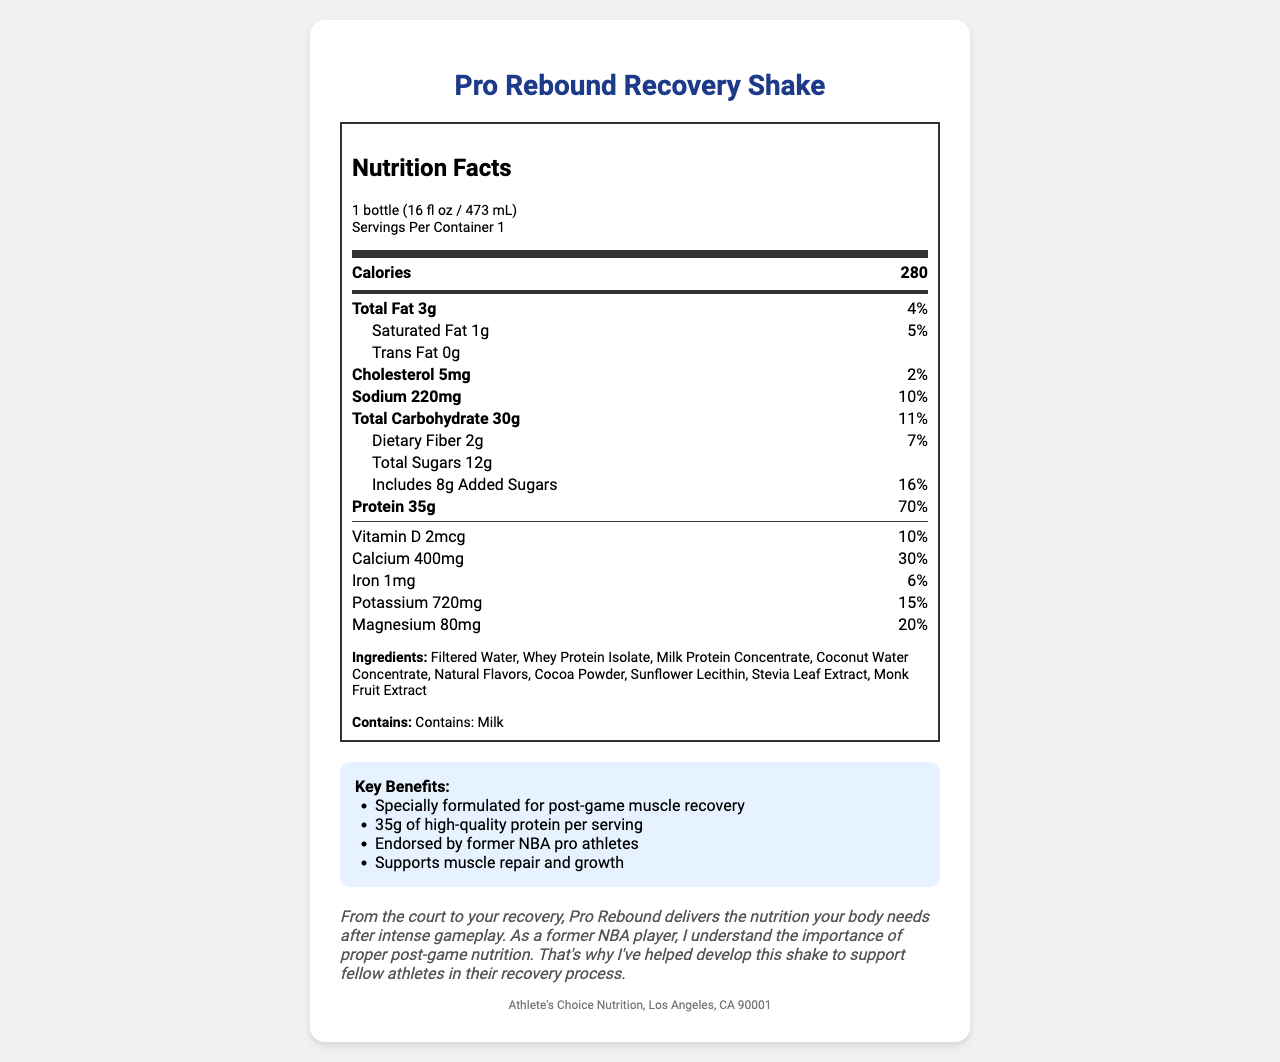what is the serving size of the Pro Rebound Recovery Shake? The serving size is clearly listed at the top of the Nutrition Facts label.
Answer: 1 bottle (16 fl oz / 473 mL) how many calories are in one serving of the shake? The total calories per serving are indicated in the main information section of the Nutrition Facts label.
Answer: 280 what is the amount of protein in the shake? The amount of protein is listed under the nutrient rows as "Protein".
Answer: 35g how much saturated fat does the shake contain? The saturated fat amount is provided in the sub-nutrient row under Total Fat.
Answer: 1g how much dietary fiber is present in one serving? The amount of dietary fiber is listed under the Total Carbohydrate section.
Answer: 2g what are the main ingredients in the shake? The ingredients are listed at the bottom of the Nutrition Facts label under the "Ingredients" section.
Answer: Filtered Water, Whey Protein Isolate, Milk Protein Concentrate, Coconut Water Concentrate, Natural Flavors, Cocoa Powder, Sunflower Lecithin, Stevia Leaf Extract, Monk Fruit Extract which of the following claims are made about the Pro Rebound Recovery Shake? A. Contains no sugar B. Endorsed by former NBA pro athletes C. High in iron The claims are listed in the "Key Benefits" section and include "Endorsed by former NBA pro athletes."
Answer: B which nutrient has the highest daily value percentage? A. Vitamin D B. Calcium C. Protein D. Potassium Protein has the highest daily value percentage at 70%.
Answer: C does the shake contain any trans fat? The document states that the amount of trans fat is 0g.
Answer: No is the shake suitable for someone with a milk allergy? The allergen statement indicates that the shake contains milk.
Answer: No summarize the main idea of the document. The document outlines the nutritional benefits and content of the Pro Rebound Recovery Shake, highlighting its high protein content and its role in muscle repair.
Answer: The document provides the nutritional information for the Pro Rebound Recovery Shake, a protein-rich drink designed for post-game muscle repair. It includes details on serving size, calorie count, and specific nutrient amounts, alongside a list of ingredients and claimed benefits. The product is endorsed by former NBA athletes and aims to support muscle recovery. what is the source of sweetener used in the shake? The document does not specify the source of the sweeteners used in the shake, such as whether they are artificial or natural.
Answer: Cannot be determined 